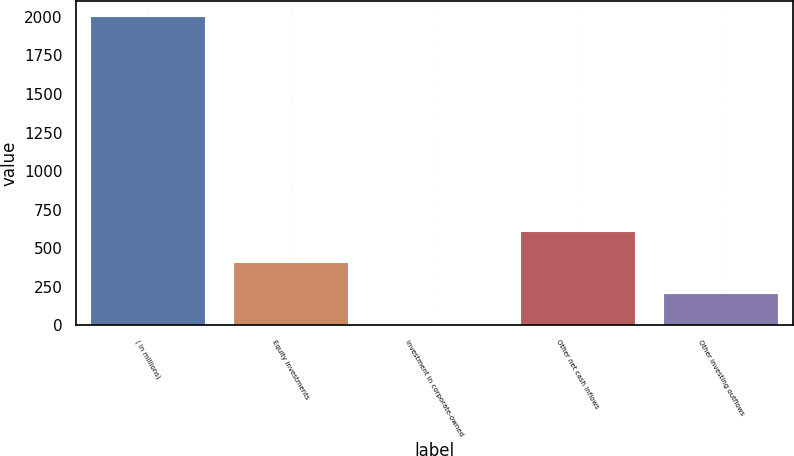Convert chart. <chart><loc_0><loc_0><loc_500><loc_500><bar_chart><fcel>( in millions)<fcel>Equity investments<fcel>Investment in corporate-owned<fcel>Other net cash inflows<fcel>Other investing outflows<nl><fcel>2003<fcel>410.2<fcel>12<fcel>609.3<fcel>211.1<nl></chart> 